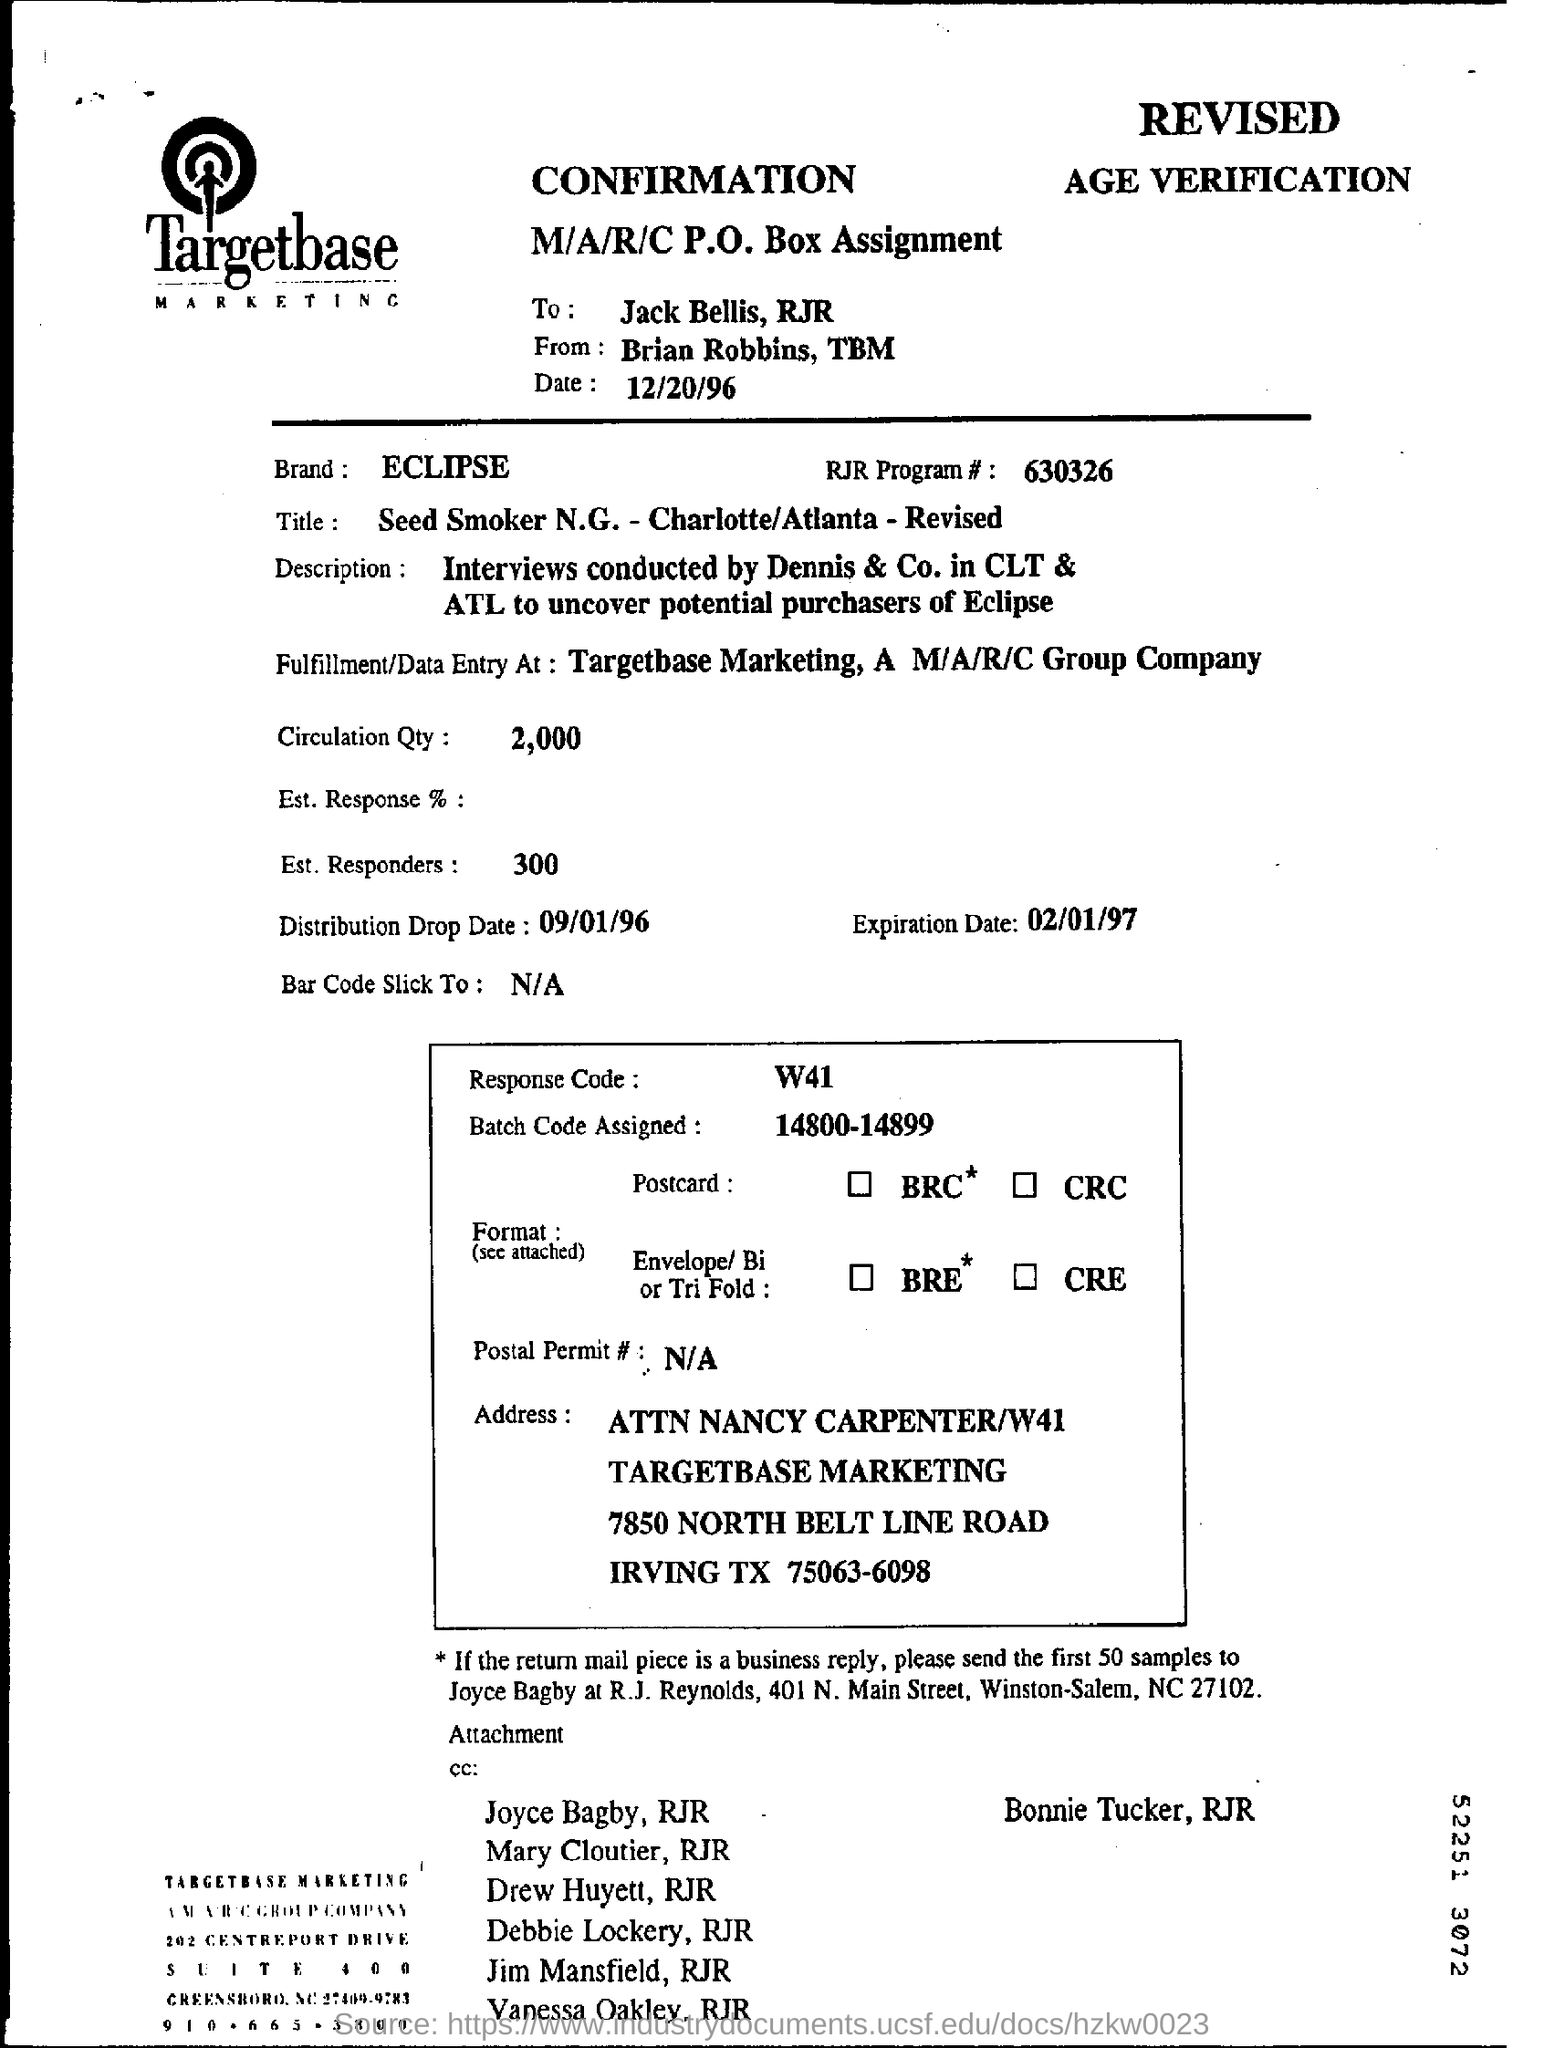Specify some key components in this picture. The confirmation of the sender is Brian Robbins from Targetbase. The brand name is ECLIPSE. The code of the response is W41. The RJR program number is 630326. 